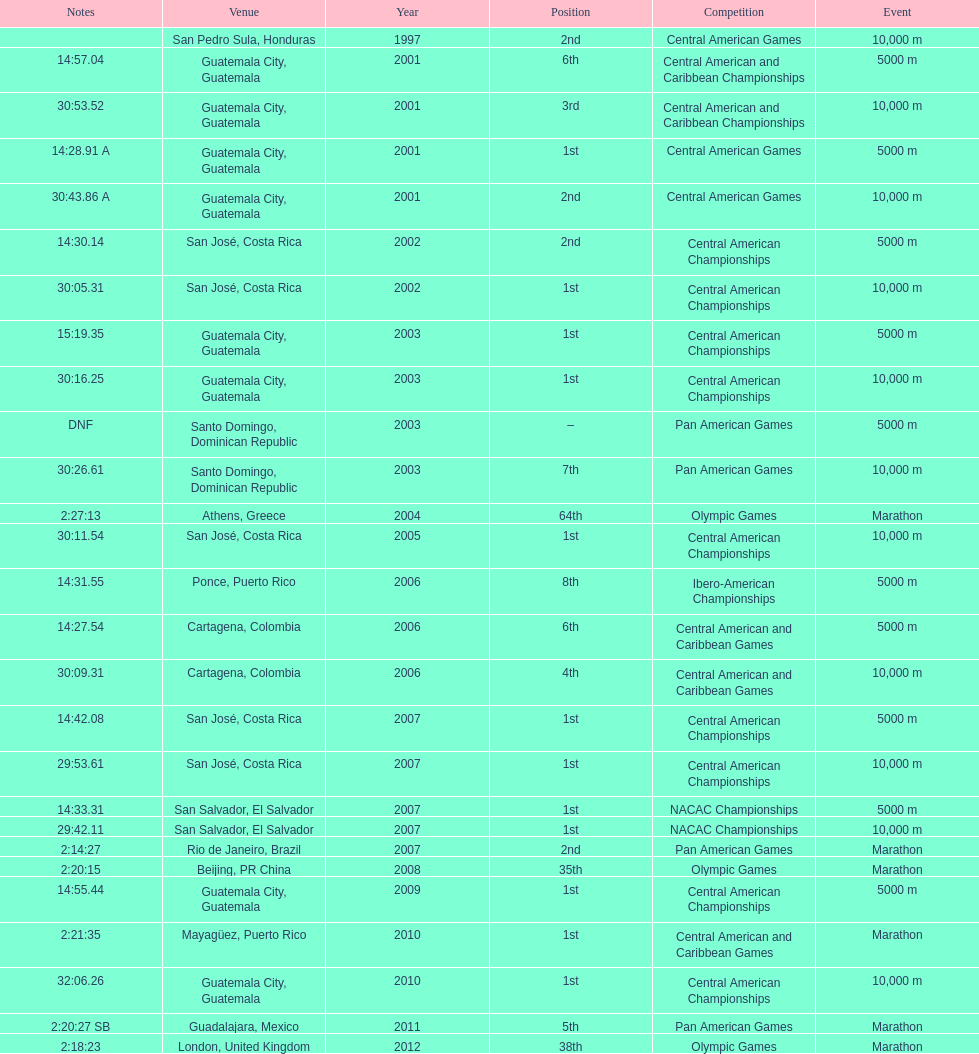Which event is listed more between the 10,000m and the 5000m? 10,000 m. 